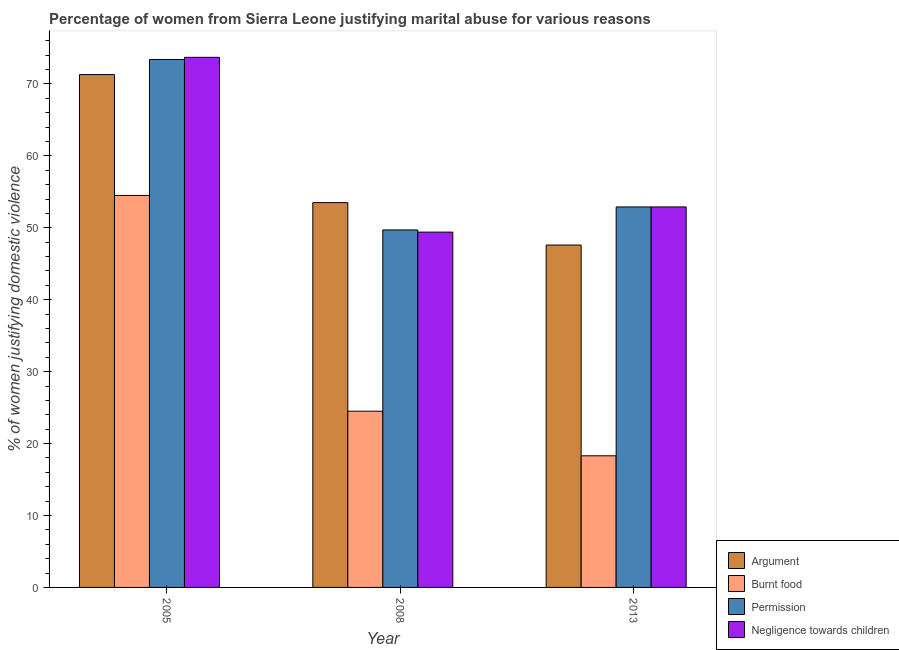How many different coloured bars are there?
Offer a terse response. 4. Are the number of bars per tick equal to the number of legend labels?
Your answer should be very brief. Yes. Are the number of bars on each tick of the X-axis equal?
Give a very brief answer. Yes. What is the label of the 2nd group of bars from the left?
Offer a terse response. 2008. What is the percentage of women justifying abuse for going without permission in 2013?
Your answer should be compact. 52.9. Across all years, what is the maximum percentage of women justifying abuse for burning food?
Make the answer very short. 54.5. Across all years, what is the minimum percentage of women justifying abuse in the case of an argument?
Your response must be concise. 47.6. In which year was the percentage of women justifying abuse for going without permission maximum?
Give a very brief answer. 2005. What is the total percentage of women justifying abuse for going without permission in the graph?
Your answer should be very brief. 176. What is the difference between the percentage of women justifying abuse for burning food in 2005 and that in 2013?
Your answer should be compact. 36.2. What is the difference between the percentage of women justifying abuse for burning food in 2005 and the percentage of women justifying abuse in the case of an argument in 2013?
Your answer should be very brief. 36.2. What is the average percentage of women justifying abuse for going without permission per year?
Your response must be concise. 58.67. What is the ratio of the percentage of women justifying abuse for going without permission in 2005 to that in 2008?
Provide a short and direct response. 1.48. Is the percentage of women justifying abuse for showing negligence towards children in 2005 less than that in 2008?
Offer a very short reply. No. Is the difference between the percentage of women justifying abuse for showing negligence towards children in 2005 and 2013 greater than the difference between the percentage of women justifying abuse for going without permission in 2005 and 2013?
Your answer should be compact. No. What is the difference between the highest and the second highest percentage of women justifying abuse for showing negligence towards children?
Your answer should be compact. 20.8. What is the difference between the highest and the lowest percentage of women justifying abuse for burning food?
Provide a succinct answer. 36.2. In how many years, is the percentage of women justifying abuse for going without permission greater than the average percentage of women justifying abuse for going without permission taken over all years?
Provide a short and direct response. 1. Is the sum of the percentage of women justifying abuse in the case of an argument in 2005 and 2008 greater than the maximum percentage of women justifying abuse for going without permission across all years?
Make the answer very short. Yes. Is it the case that in every year, the sum of the percentage of women justifying abuse for going without permission and percentage of women justifying abuse for showing negligence towards children is greater than the sum of percentage of women justifying abuse in the case of an argument and percentage of women justifying abuse for burning food?
Offer a terse response. No. What does the 3rd bar from the left in 2013 represents?
Provide a succinct answer. Permission. What does the 4th bar from the right in 2008 represents?
Ensure brevity in your answer.  Argument. Are all the bars in the graph horizontal?
Ensure brevity in your answer.  No. Does the graph contain any zero values?
Ensure brevity in your answer.  No. Does the graph contain grids?
Your answer should be compact. No. How many legend labels are there?
Offer a terse response. 4. What is the title of the graph?
Your response must be concise. Percentage of women from Sierra Leone justifying marital abuse for various reasons. What is the label or title of the Y-axis?
Provide a succinct answer. % of women justifying domestic violence. What is the % of women justifying domestic violence in Argument in 2005?
Provide a succinct answer. 71.3. What is the % of women justifying domestic violence of Burnt food in 2005?
Give a very brief answer. 54.5. What is the % of women justifying domestic violence of Permission in 2005?
Make the answer very short. 73.4. What is the % of women justifying domestic violence of Negligence towards children in 2005?
Provide a short and direct response. 73.7. What is the % of women justifying domestic violence in Argument in 2008?
Ensure brevity in your answer.  53.5. What is the % of women justifying domestic violence of Burnt food in 2008?
Ensure brevity in your answer.  24.5. What is the % of women justifying domestic violence of Permission in 2008?
Provide a short and direct response. 49.7. What is the % of women justifying domestic violence of Negligence towards children in 2008?
Your answer should be very brief. 49.4. What is the % of women justifying domestic violence of Argument in 2013?
Give a very brief answer. 47.6. What is the % of women justifying domestic violence in Burnt food in 2013?
Your answer should be compact. 18.3. What is the % of women justifying domestic violence of Permission in 2013?
Your answer should be compact. 52.9. What is the % of women justifying domestic violence of Negligence towards children in 2013?
Offer a terse response. 52.9. Across all years, what is the maximum % of women justifying domestic violence of Argument?
Provide a short and direct response. 71.3. Across all years, what is the maximum % of women justifying domestic violence of Burnt food?
Provide a succinct answer. 54.5. Across all years, what is the maximum % of women justifying domestic violence of Permission?
Keep it short and to the point. 73.4. Across all years, what is the maximum % of women justifying domestic violence of Negligence towards children?
Offer a very short reply. 73.7. Across all years, what is the minimum % of women justifying domestic violence in Argument?
Provide a short and direct response. 47.6. Across all years, what is the minimum % of women justifying domestic violence in Permission?
Ensure brevity in your answer.  49.7. Across all years, what is the minimum % of women justifying domestic violence in Negligence towards children?
Offer a very short reply. 49.4. What is the total % of women justifying domestic violence of Argument in the graph?
Your answer should be very brief. 172.4. What is the total % of women justifying domestic violence in Burnt food in the graph?
Your answer should be compact. 97.3. What is the total % of women justifying domestic violence in Permission in the graph?
Make the answer very short. 176. What is the total % of women justifying domestic violence in Negligence towards children in the graph?
Offer a very short reply. 176. What is the difference between the % of women justifying domestic violence of Argument in 2005 and that in 2008?
Provide a succinct answer. 17.8. What is the difference between the % of women justifying domestic violence of Burnt food in 2005 and that in 2008?
Ensure brevity in your answer.  30. What is the difference between the % of women justifying domestic violence of Permission in 2005 and that in 2008?
Provide a succinct answer. 23.7. What is the difference between the % of women justifying domestic violence of Negligence towards children in 2005 and that in 2008?
Your response must be concise. 24.3. What is the difference between the % of women justifying domestic violence in Argument in 2005 and that in 2013?
Your answer should be compact. 23.7. What is the difference between the % of women justifying domestic violence in Burnt food in 2005 and that in 2013?
Your response must be concise. 36.2. What is the difference between the % of women justifying domestic violence of Negligence towards children in 2005 and that in 2013?
Give a very brief answer. 20.8. What is the difference between the % of women justifying domestic violence in Argument in 2008 and that in 2013?
Your answer should be compact. 5.9. What is the difference between the % of women justifying domestic violence of Argument in 2005 and the % of women justifying domestic violence of Burnt food in 2008?
Give a very brief answer. 46.8. What is the difference between the % of women justifying domestic violence in Argument in 2005 and the % of women justifying domestic violence in Permission in 2008?
Give a very brief answer. 21.6. What is the difference between the % of women justifying domestic violence of Argument in 2005 and the % of women justifying domestic violence of Negligence towards children in 2008?
Provide a succinct answer. 21.9. What is the difference between the % of women justifying domestic violence in Permission in 2005 and the % of women justifying domestic violence in Negligence towards children in 2008?
Ensure brevity in your answer.  24. What is the difference between the % of women justifying domestic violence of Argument in 2005 and the % of women justifying domestic violence of Burnt food in 2013?
Your response must be concise. 53. What is the difference between the % of women justifying domestic violence of Argument in 2005 and the % of women justifying domestic violence of Permission in 2013?
Ensure brevity in your answer.  18.4. What is the difference between the % of women justifying domestic violence in Burnt food in 2005 and the % of women justifying domestic violence in Permission in 2013?
Provide a short and direct response. 1.6. What is the difference between the % of women justifying domestic violence in Argument in 2008 and the % of women justifying domestic violence in Burnt food in 2013?
Your answer should be compact. 35.2. What is the difference between the % of women justifying domestic violence of Argument in 2008 and the % of women justifying domestic violence of Permission in 2013?
Provide a short and direct response. 0.6. What is the difference between the % of women justifying domestic violence of Argument in 2008 and the % of women justifying domestic violence of Negligence towards children in 2013?
Your response must be concise. 0.6. What is the difference between the % of women justifying domestic violence of Burnt food in 2008 and the % of women justifying domestic violence of Permission in 2013?
Provide a succinct answer. -28.4. What is the difference between the % of women justifying domestic violence in Burnt food in 2008 and the % of women justifying domestic violence in Negligence towards children in 2013?
Provide a short and direct response. -28.4. What is the difference between the % of women justifying domestic violence of Permission in 2008 and the % of women justifying domestic violence of Negligence towards children in 2013?
Offer a very short reply. -3.2. What is the average % of women justifying domestic violence in Argument per year?
Keep it short and to the point. 57.47. What is the average % of women justifying domestic violence in Burnt food per year?
Offer a very short reply. 32.43. What is the average % of women justifying domestic violence in Permission per year?
Make the answer very short. 58.67. What is the average % of women justifying domestic violence of Negligence towards children per year?
Your answer should be very brief. 58.67. In the year 2005, what is the difference between the % of women justifying domestic violence in Argument and % of women justifying domestic violence in Burnt food?
Provide a short and direct response. 16.8. In the year 2005, what is the difference between the % of women justifying domestic violence in Argument and % of women justifying domestic violence in Permission?
Offer a very short reply. -2.1. In the year 2005, what is the difference between the % of women justifying domestic violence in Burnt food and % of women justifying domestic violence in Permission?
Your response must be concise. -18.9. In the year 2005, what is the difference between the % of women justifying domestic violence of Burnt food and % of women justifying domestic violence of Negligence towards children?
Give a very brief answer. -19.2. In the year 2008, what is the difference between the % of women justifying domestic violence in Burnt food and % of women justifying domestic violence in Permission?
Offer a very short reply. -25.2. In the year 2008, what is the difference between the % of women justifying domestic violence in Burnt food and % of women justifying domestic violence in Negligence towards children?
Your answer should be very brief. -24.9. In the year 2008, what is the difference between the % of women justifying domestic violence in Permission and % of women justifying domestic violence in Negligence towards children?
Your answer should be very brief. 0.3. In the year 2013, what is the difference between the % of women justifying domestic violence in Argument and % of women justifying domestic violence in Burnt food?
Ensure brevity in your answer.  29.3. In the year 2013, what is the difference between the % of women justifying domestic violence in Argument and % of women justifying domestic violence in Permission?
Your answer should be compact. -5.3. In the year 2013, what is the difference between the % of women justifying domestic violence of Burnt food and % of women justifying domestic violence of Permission?
Offer a very short reply. -34.6. In the year 2013, what is the difference between the % of women justifying domestic violence of Burnt food and % of women justifying domestic violence of Negligence towards children?
Your response must be concise. -34.6. What is the ratio of the % of women justifying domestic violence of Argument in 2005 to that in 2008?
Your answer should be very brief. 1.33. What is the ratio of the % of women justifying domestic violence in Burnt food in 2005 to that in 2008?
Ensure brevity in your answer.  2.22. What is the ratio of the % of women justifying domestic violence in Permission in 2005 to that in 2008?
Your answer should be very brief. 1.48. What is the ratio of the % of women justifying domestic violence of Negligence towards children in 2005 to that in 2008?
Your answer should be compact. 1.49. What is the ratio of the % of women justifying domestic violence in Argument in 2005 to that in 2013?
Your answer should be compact. 1.5. What is the ratio of the % of women justifying domestic violence in Burnt food in 2005 to that in 2013?
Ensure brevity in your answer.  2.98. What is the ratio of the % of women justifying domestic violence of Permission in 2005 to that in 2013?
Offer a terse response. 1.39. What is the ratio of the % of women justifying domestic violence in Negligence towards children in 2005 to that in 2013?
Provide a short and direct response. 1.39. What is the ratio of the % of women justifying domestic violence of Argument in 2008 to that in 2013?
Offer a very short reply. 1.12. What is the ratio of the % of women justifying domestic violence in Burnt food in 2008 to that in 2013?
Give a very brief answer. 1.34. What is the ratio of the % of women justifying domestic violence in Permission in 2008 to that in 2013?
Offer a very short reply. 0.94. What is the ratio of the % of women justifying domestic violence in Negligence towards children in 2008 to that in 2013?
Your answer should be compact. 0.93. What is the difference between the highest and the second highest % of women justifying domestic violence in Burnt food?
Your answer should be very brief. 30. What is the difference between the highest and the second highest % of women justifying domestic violence in Negligence towards children?
Your answer should be very brief. 20.8. What is the difference between the highest and the lowest % of women justifying domestic violence in Argument?
Give a very brief answer. 23.7. What is the difference between the highest and the lowest % of women justifying domestic violence in Burnt food?
Provide a succinct answer. 36.2. What is the difference between the highest and the lowest % of women justifying domestic violence of Permission?
Give a very brief answer. 23.7. What is the difference between the highest and the lowest % of women justifying domestic violence in Negligence towards children?
Your response must be concise. 24.3. 